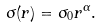Convert formula to latex. <formula><loc_0><loc_0><loc_500><loc_500>\sigma ( r ) = \sigma _ { 0 } r ^ { \alpha } .</formula> 